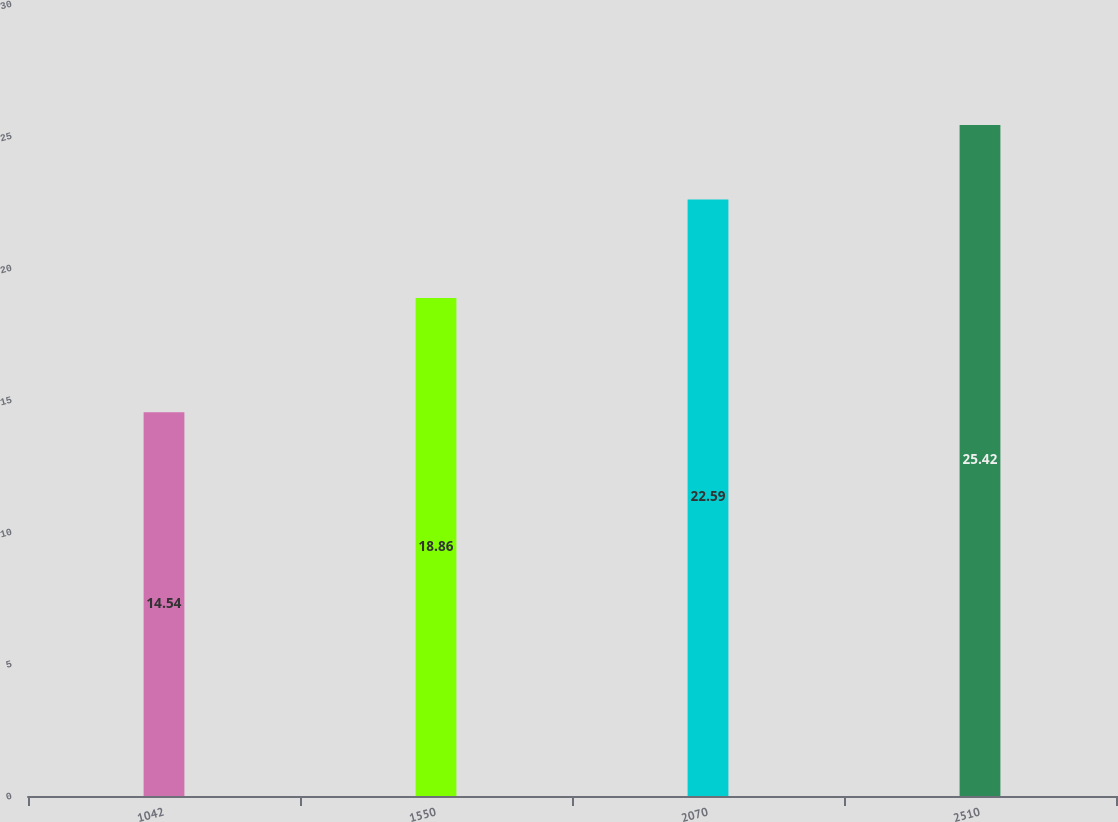Convert chart. <chart><loc_0><loc_0><loc_500><loc_500><bar_chart><fcel>1042<fcel>1550<fcel>2070<fcel>2510<nl><fcel>14.54<fcel>18.86<fcel>22.59<fcel>25.42<nl></chart> 